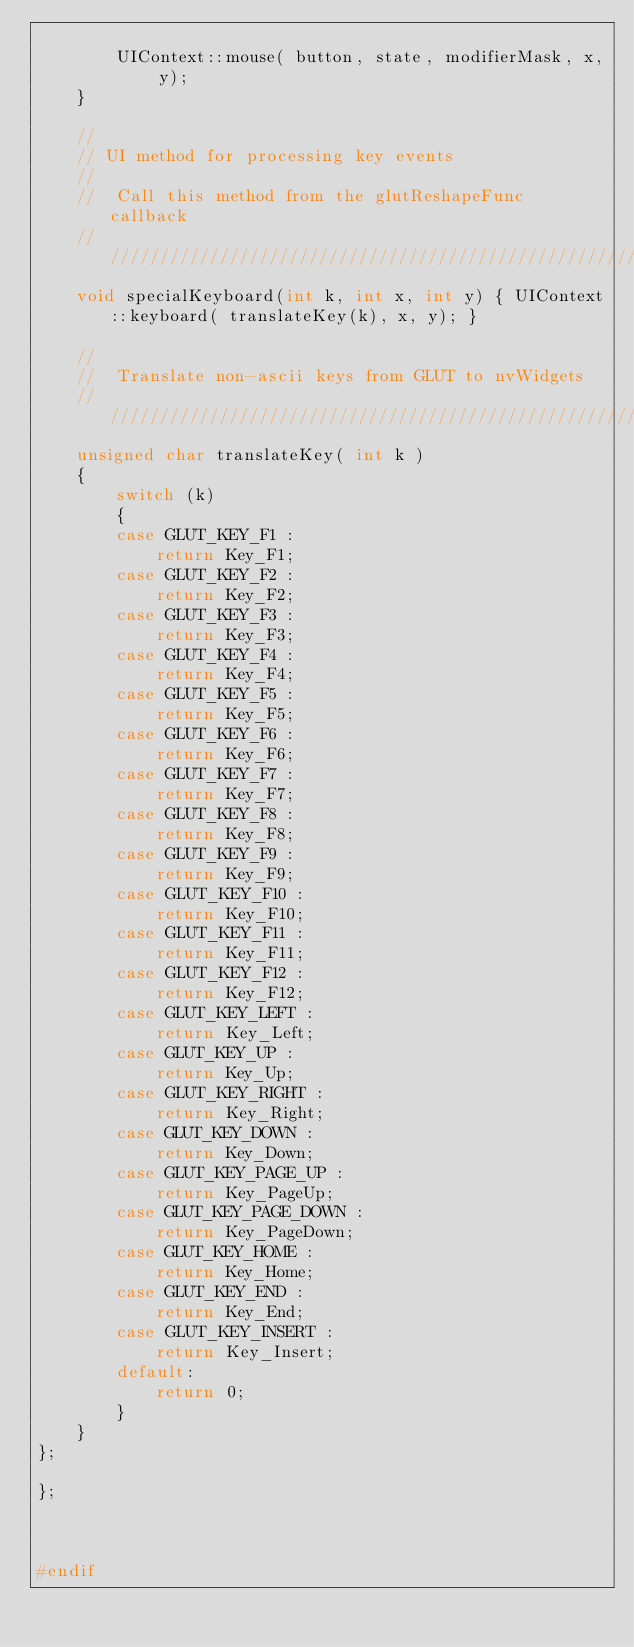<code> <loc_0><loc_0><loc_500><loc_500><_C_>
        UIContext::mouse( button, state, modifierMask, x, y);
    }

    //
    // UI method for processing key events
    //
    //  Call this method from the glutReshapeFunc callback
    //////////////////////////////////////////////////////////////////
    void specialKeyboard(int k, int x, int y) { UIContext::keyboard( translateKey(k), x, y); }

    //
    //  Translate non-ascii keys from GLUT to nvWidgets
    //////////////////////////////////////////////////////////////////
    unsigned char translateKey( int k )
    {
        switch (k)
        {
        case GLUT_KEY_F1 :
            return Key_F1;
        case GLUT_KEY_F2 :
            return Key_F2;
        case GLUT_KEY_F3 :
            return Key_F3;
        case GLUT_KEY_F4 :
            return Key_F4;
        case GLUT_KEY_F5 :
            return Key_F5;
        case GLUT_KEY_F6 :
            return Key_F6;
        case GLUT_KEY_F7 :
            return Key_F7;
        case GLUT_KEY_F8 :
            return Key_F8;
        case GLUT_KEY_F9 :
            return Key_F9;
        case GLUT_KEY_F10 :
            return Key_F10;
        case GLUT_KEY_F11 :
            return Key_F11;
        case GLUT_KEY_F12 :
            return Key_F12;
        case GLUT_KEY_LEFT :
            return Key_Left;
        case GLUT_KEY_UP :
            return Key_Up;
        case GLUT_KEY_RIGHT :
            return Key_Right;
        case GLUT_KEY_DOWN :
            return Key_Down;
        case GLUT_KEY_PAGE_UP :
            return Key_PageUp;
        case GLUT_KEY_PAGE_DOWN :
            return Key_PageDown;
        case GLUT_KEY_HOME :
            return Key_Home;
        case GLUT_KEY_END :
            return Key_End;
        case GLUT_KEY_INSERT :
            return Key_Insert;
        default:
            return 0;
        } 
    }
};

};



#endif
</code> 